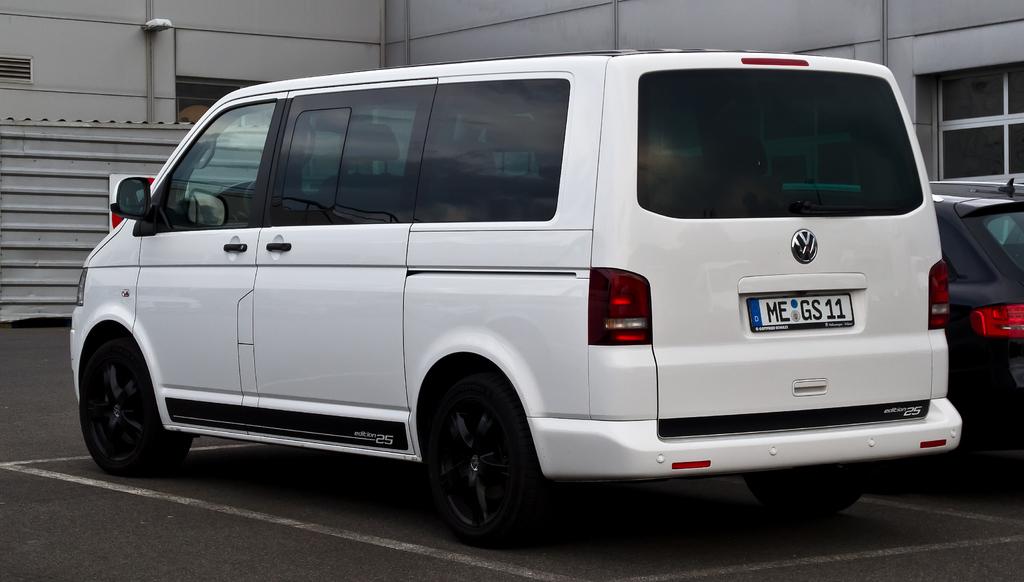What is the license plate number?
Keep it short and to the point. Megs11. 